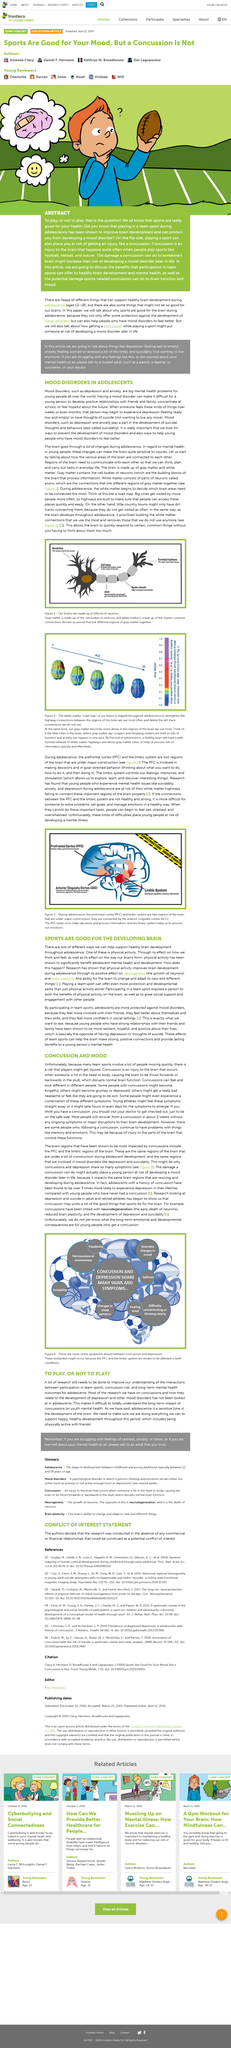Give some essential details in this illustration. Weak connections between the prefrontal cortex and limbic system in adolescents can impair their ability to perform tasks such as problem solving, setting goals, and emotional management, making these tasks more difficult. Young athletes may experience the symptoms of concussion immediately or several hours after sustaining a head injury. It is called suicidality, the development of suicidal thoughts. In mood disorders, two examples are depression and anxiety. The impact of concussion on the mental health of young people is a complex and multifaceted issue that requires further research and connections to be fully understood. 